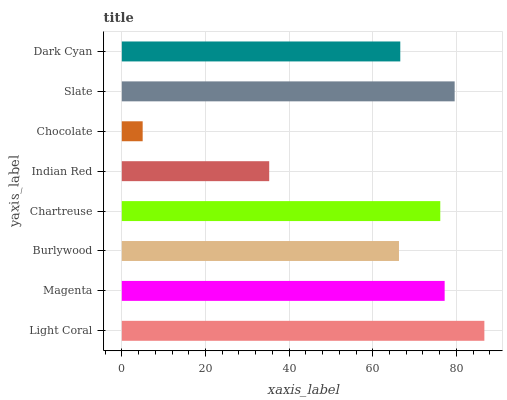Is Chocolate the minimum?
Answer yes or no. Yes. Is Light Coral the maximum?
Answer yes or no. Yes. Is Magenta the minimum?
Answer yes or no. No. Is Magenta the maximum?
Answer yes or no. No. Is Light Coral greater than Magenta?
Answer yes or no. Yes. Is Magenta less than Light Coral?
Answer yes or no. Yes. Is Magenta greater than Light Coral?
Answer yes or no. No. Is Light Coral less than Magenta?
Answer yes or no. No. Is Chartreuse the high median?
Answer yes or no. Yes. Is Dark Cyan the low median?
Answer yes or no. Yes. Is Slate the high median?
Answer yes or no. No. Is Chartreuse the low median?
Answer yes or no. No. 